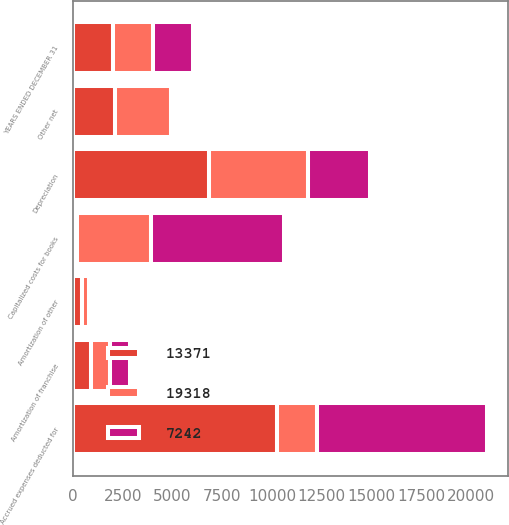Convert chart. <chart><loc_0><loc_0><loc_500><loc_500><stacked_bar_chart><ecel><fcel>YEARS ENDED DECEMBER 31<fcel>Amortization of franchise<fcel>Amortization of other<fcel>Accrued expenses deducted for<fcel>Capitalized costs for books<fcel>Depreciation<fcel>Other net<nl><fcel>7242<fcel>2007<fcel>994<fcel>214<fcel>8544<fcel>6701<fcel>3146<fcel>209<nl><fcel>19318<fcel>2006<fcel>972<fcel>339<fcel>2006.5<fcel>3673<fcel>4980<fcel>2832<nl><fcel>13371<fcel>2005<fcel>912<fcel>449<fcel>10239<fcel>226<fcel>6815<fcel>2096<nl></chart> 